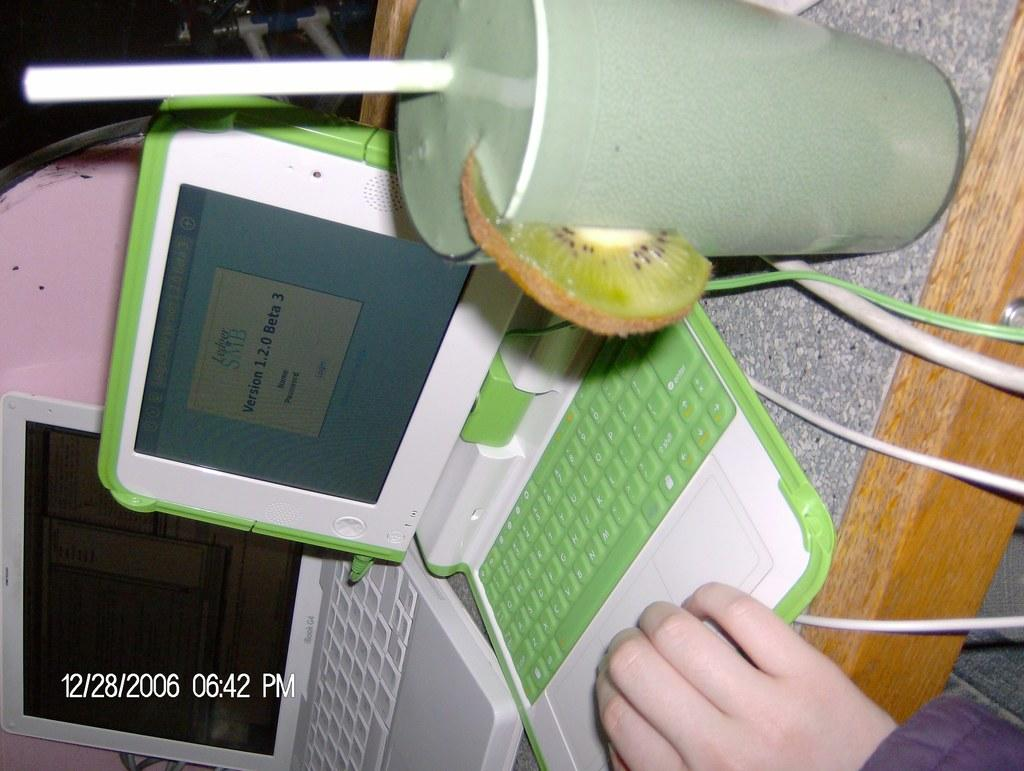What is located in the foreground of the image? There is a table in the foreground of the image. What electronic devices are on the table? Laptops are present on the table. What type of beverage container is on the table? A juice glass is on the table. What else can be seen on the table? Wires are visible on the table. Can you describe any body parts visible in the image? A person's hand is visible in the image. Where was the image taken? The image was taken in a room. What type of acoustics can be heard in the room in the image? There is no information about the acoustics in the room in the image. Is there a train visible in the image? No, there is no train present in the image. 